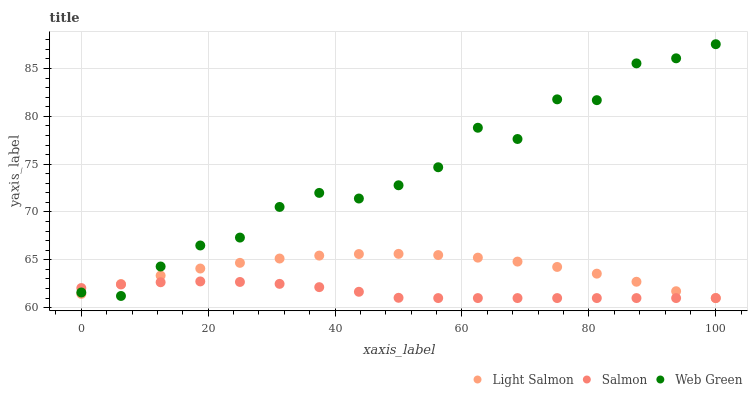Does Salmon have the minimum area under the curve?
Answer yes or no. Yes. Does Web Green have the maximum area under the curve?
Answer yes or no. Yes. Does Web Green have the minimum area under the curve?
Answer yes or no. No. Does Salmon have the maximum area under the curve?
Answer yes or no. No. Is Salmon the smoothest?
Answer yes or no. Yes. Is Web Green the roughest?
Answer yes or no. Yes. Is Web Green the smoothest?
Answer yes or no. No. Is Salmon the roughest?
Answer yes or no. No. Does Light Salmon have the lowest value?
Answer yes or no. Yes. Does Web Green have the lowest value?
Answer yes or no. No. Does Web Green have the highest value?
Answer yes or no. Yes. Does Salmon have the highest value?
Answer yes or no. No. Does Salmon intersect Web Green?
Answer yes or no. Yes. Is Salmon less than Web Green?
Answer yes or no. No. Is Salmon greater than Web Green?
Answer yes or no. No. 